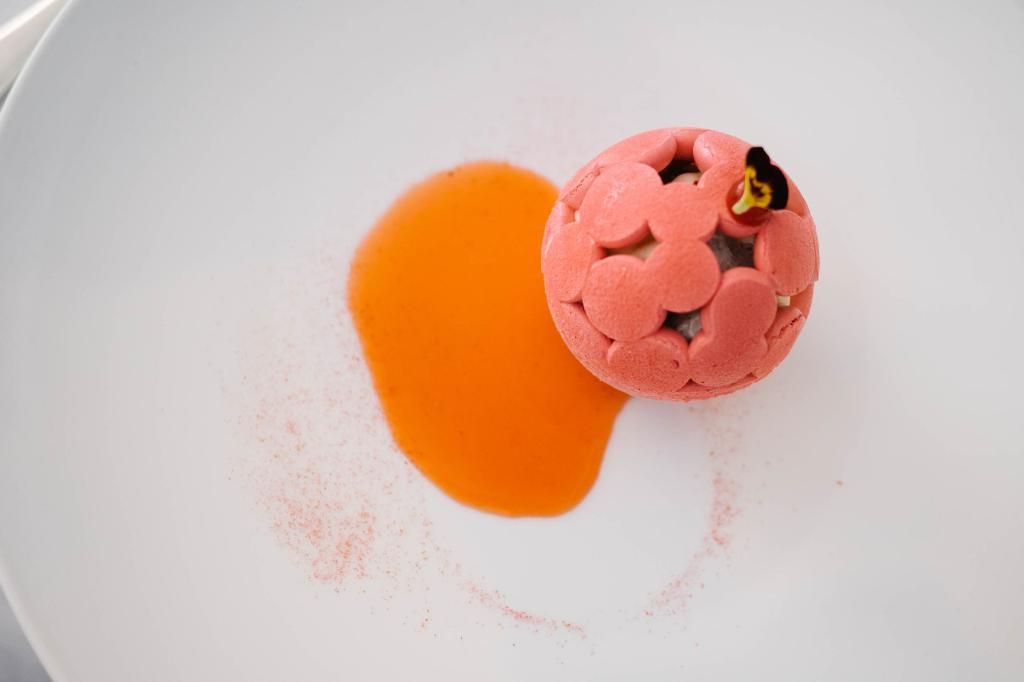What is the color of the main object in the image? The main object in the image is white. What is placed on the white object? There is a pink and orange object on the white object. What type of bell can be heard ringing in the image? There is no bell present in the image, and therefore no sound can be heard. 